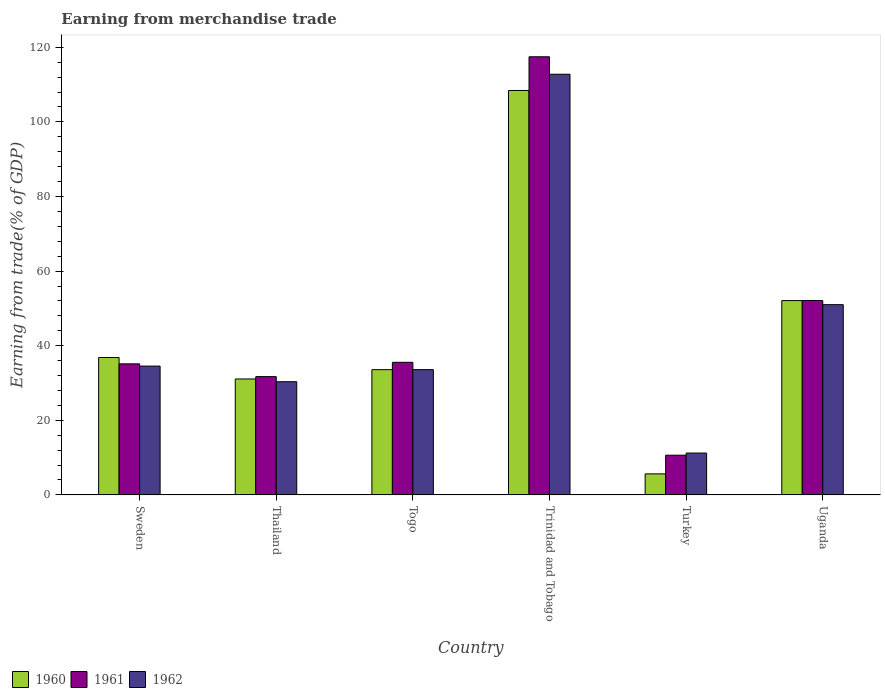How many groups of bars are there?
Your answer should be compact. 6. Are the number of bars per tick equal to the number of legend labels?
Your response must be concise. Yes. Are the number of bars on each tick of the X-axis equal?
Your answer should be compact. Yes. How many bars are there on the 2nd tick from the left?
Ensure brevity in your answer.  3. How many bars are there on the 5th tick from the right?
Provide a succinct answer. 3. What is the label of the 3rd group of bars from the left?
Make the answer very short. Togo. In how many cases, is the number of bars for a given country not equal to the number of legend labels?
Provide a succinct answer. 0. What is the earnings from trade in 1960 in Togo?
Give a very brief answer. 33.58. Across all countries, what is the maximum earnings from trade in 1961?
Ensure brevity in your answer.  117.45. Across all countries, what is the minimum earnings from trade in 1961?
Ensure brevity in your answer.  10.64. In which country was the earnings from trade in 1961 maximum?
Your response must be concise. Trinidad and Tobago. What is the total earnings from trade in 1962 in the graph?
Offer a terse response. 273.44. What is the difference between the earnings from trade in 1960 in Turkey and that in Uganda?
Provide a short and direct response. -46.45. What is the difference between the earnings from trade in 1962 in Uganda and the earnings from trade in 1961 in Sweden?
Make the answer very short. 15.86. What is the average earnings from trade in 1961 per country?
Your answer should be very brief. 47.1. What is the difference between the earnings from trade of/in 1961 and earnings from trade of/in 1962 in Sweden?
Keep it short and to the point. 0.6. In how many countries, is the earnings from trade in 1961 greater than 108 %?
Keep it short and to the point. 1. What is the ratio of the earnings from trade in 1962 in Togo to that in Trinidad and Tobago?
Ensure brevity in your answer.  0.3. Is the difference between the earnings from trade in 1961 in Sweden and Togo greater than the difference between the earnings from trade in 1962 in Sweden and Togo?
Ensure brevity in your answer.  No. What is the difference between the highest and the second highest earnings from trade in 1962?
Make the answer very short. 61.77. What is the difference between the highest and the lowest earnings from trade in 1960?
Provide a succinct answer. 102.78. In how many countries, is the earnings from trade in 1960 greater than the average earnings from trade in 1960 taken over all countries?
Your answer should be very brief. 2. What does the 2nd bar from the left in Thailand represents?
Your answer should be very brief. 1961. Are all the bars in the graph horizontal?
Provide a short and direct response. No. How many countries are there in the graph?
Provide a short and direct response. 6. What is the difference between two consecutive major ticks on the Y-axis?
Provide a short and direct response. 20. Are the values on the major ticks of Y-axis written in scientific E-notation?
Make the answer very short. No. How many legend labels are there?
Ensure brevity in your answer.  3. How are the legend labels stacked?
Your answer should be compact. Horizontal. What is the title of the graph?
Your answer should be very brief. Earning from merchandise trade. What is the label or title of the Y-axis?
Provide a succinct answer. Earning from trade(% of GDP). What is the Earning from trade(% of GDP) in 1960 in Sweden?
Your answer should be compact. 36.83. What is the Earning from trade(% of GDP) of 1961 in Sweden?
Give a very brief answer. 35.13. What is the Earning from trade(% of GDP) in 1962 in Sweden?
Your answer should be very brief. 34.53. What is the Earning from trade(% of GDP) of 1960 in Thailand?
Your response must be concise. 31.08. What is the Earning from trade(% of GDP) in 1961 in Thailand?
Your response must be concise. 31.71. What is the Earning from trade(% of GDP) in 1962 in Thailand?
Give a very brief answer. 30.34. What is the Earning from trade(% of GDP) in 1960 in Togo?
Your answer should be very brief. 33.58. What is the Earning from trade(% of GDP) of 1961 in Togo?
Offer a very short reply. 35.55. What is the Earning from trade(% of GDP) in 1962 in Togo?
Give a very brief answer. 33.58. What is the Earning from trade(% of GDP) in 1960 in Trinidad and Tobago?
Keep it short and to the point. 108.42. What is the Earning from trade(% of GDP) in 1961 in Trinidad and Tobago?
Provide a short and direct response. 117.45. What is the Earning from trade(% of GDP) of 1962 in Trinidad and Tobago?
Give a very brief answer. 112.77. What is the Earning from trade(% of GDP) in 1960 in Turkey?
Provide a short and direct response. 5.64. What is the Earning from trade(% of GDP) of 1961 in Turkey?
Provide a succinct answer. 10.64. What is the Earning from trade(% of GDP) in 1962 in Turkey?
Provide a short and direct response. 11.21. What is the Earning from trade(% of GDP) of 1960 in Uganda?
Your response must be concise. 52.09. What is the Earning from trade(% of GDP) of 1961 in Uganda?
Keep it short and to the point. 52.12. What is the Earning from trade(% of GDP) in 1962 in Uganda?
Make the answer very short. 51. Across all countries, what is the maximum Earning from trade(% of GDP) in 1960?
Your answer should be compact. 108.42. Across all countries, what is the maximum Earning from trade(% of GDP) in 1961?
Your answer should be very brief. 117.45. Across all countries, what is the maximum Earning from trade(% of GDP) of 1962?
Your answer should be compact. 112.77. Across all countries, what is the minimum Earning from trade(% of GDP) in 1960?
Your answer should be very brief. 5.64. Across all countries, what is the minimum Earning from trade(% of GDP) of 1961?
Keep it short and to the point. 10.64. Across all countries, what is the minimum Earning from trade(% of GDP) in 1962?
Keep it short and to the point. 11.21. What is the total Earning from trade(% of GDP) of 1960 in the graph?
Your answer should be very brief. 267.63. What is the total Earning from trade(% of GDP) in 1961 in the graph?
Ensure brevity in your answer.  282.6. What is the total Earning from trade(% of GDP) of 1962 in the graph?
Your answer should be very brief. 273.44. What is the difference between the Earning from trade(% of GDP) in 1960 in Sweden and that in Thailand?
Your response must be concise. 5.75. What is the difference between the Earning from trade(% of GDP) of 1961 in Sweden and that in Thailand?
Make the answer very short. 3.43. What is the difference between the Earning from trade(% of GDP) of 1962 in Sweden and that in Thailand?
Make the answer very short. 4.19. What is the difference between the Earning from trade(% of GDP) in 1960 in Sweden and that in Togo?
Ensure brevity in your answer.  3.25. What is the difference between the Earning from trade(% of GDP) of 1961 in Sweden and that in Togo?
Keep it short and to the point. -0.41. What is the difference between the Earning from trade(% of GDP) of 1962 in Sweden and that in Togo?
Ensure brevity in your answer.  0.95. What is the difference between the Earning from trade(% of GDP) of 1960 in Sweden and that in Trinidad and Tobago?
Make the answer very short. -71.59. What is the difference between the Earning from trade(% of GDP) of 1961 in Sweden and that in Trinidad and Tobago?
Your answer should be compact. -82.32. What is the difference between the Earning from trade(% of GDP) in 1962 in Sweden and that in Trinidad and Tobago?
Offer a terse response. -78.24. What is the difference between the Earning from trade(% of GDP) in 1960 in Sweden and that in Turkey?
Provide a succinct answer. 31.2. What is the difference between the Earning from trade(% of GDP) of 1961 in Sweden and that in Turkey?
Make the answer very short. 24.49. What is the difference between the Earning from trade(% of GDP) in 1962 in Sweden and that in Turkey?
Provide a short and direct response. 23.32. What is the difference between the Earning from trade(% of GDP) in 1960 in Sweden and that in Uganda?
Your answer should be very brief. -15.26. What is the difference between the Earning from trade(% of GDP) of 1961 in Sweden and that in Uganda?
Your response must be concise. -16.99. What is the difference between the Earning from trade(% of GDP) of 1962 in Sweden and that in Uganda?
Your answer should be compact. -16.46. What is the difference between the Earning from trade(% of GDP) of 1960 in Thailand and that in Togo?
Your answer should be compact. -2.5. What is the difference between the Earning from trade(% of GDP) of 1961 in Thailand and that in Togo?
Make the answer very short. -3.84. What is the difference between the Earning from trade(% of GDP) in 1962 in Thailand and that in Togo?
Give a very brief answer. -3.24. What is the difference between the Earning from trade(% of GDP) in 1960 in Thailand and that in Trinidad and Tobago?
Your response must be concise. -77.34. What is the difference between the Earning from trade(% of GDP) in 1961 in Thailand and that in Trinidad and Tobago?
Provide a short and direct response. -85.74. What is the difference between the Earning from trade(% of GDP) of 1962 in Thailand and that in Trinidad and Tobago?
Offer a terse response. -82.43. What is the difference between the Earning from trade(% of GDP) in 1960 in Thailand and that in Turkey?
Ensure brevity in your answer.  25.44. What is the difference between the Earning from trade(% of GDP) in 1961 in Thailand and that in Turkey?
Ensure brevity in your answer.  21.06. What is the difference between the Earning from trade(% of GDP) in 1962 in Thailand and that in Turkey?
Give a very brief answer. 19.13. What is the difference between the Earning from trade(% of GDP) of 1960 in Thailand and that in Uganda?
Provide a succinct answer. -21.01. What is the difference between the Earning from trade(% of GDP) in 1961 in Thailand and that in Uganda?
Give a very brief answer. -20.41. What is the difference between the Earning from trade(% of GDP) of 1962 in Thailand and that in Uganda?
Keep it short and to the point. -20.65. What is the difference between the Earning from trade(% of GDP) in 1960 in Togo and that in Trinidad and Tobago?
Your answer should be compact. -74.84. What is the difference between the Earning from trade(% of GDP) in 1961 in Togo and that in Trinidad and Tobago?
Ensure brevity in your answer.  -81.9. What is the difference between the Earning from trade(% of GDP) in 1962 in Togo and that in Trinidad and Tobago?
Your response must be concise. -79.19. What is the difference between the Earning from trade(% of GDP) in 1960 in Togo and that in Turkey?
Provide a short and direct response. 27.94. What is the difference between the Earning from trade(% of GDP) of 1961 in Togo and that in Turkey?
Provide a short and direct response. 24.9. What is the difference between the Earning from trade(% of GDP) of 1962 in Togo and that in Turkey?
Provide a short and direct response. 22.37. What is the difference between the Earning from trade(% of GDP) in 1960 in Togo and that in Uganda?
Provide a succinct answer. -18.51. What is the difference between the Earning from trade(% of GDP) in 1961 in Togo and that in Uganda?
Offer a terse response. -16.57. What is the difference between the Earning from trade(% of GDP) of 1962 in Togo and that in Uganda?
Ensure brevity in your answer.  -17.41. What is the difference between the Earning from trade(% of GDP) of 1960 in Trinidad and Tobago and that in Turkey?
Your response must be concise. 102.78. What is the difference between the Earning from trade(% of GDP) in 1961 in Trinidad and Tobago and that in Turkey?
Give a very brief answer. 106.81. What is the difference between the Earning from trade(% of GDP) in 1962 in Trinidad and Tobago and that in Turkey?
Provide a succinct answer. 101.56. What is the difference between the Earning from trade(% of GDP) of 1960 in Trinidad and Tobago and that in Uganda?
Your answer should be very brief. 56.33. What is the difference between the Earning from trade(% of GDP) of 1961 in Trinidad and Tobago and that in Uganda?
Make the answer very short. 65.33. What is the difference between the Earning from trade(% of GDP) of 1962 in Trinidad and Tobago and that in Uganda?
Your answer should be compact. 61.77. What is the difference between the Earning from trade(% of GDP) in 1960 in Turkey and that in Uganda?
Give a very brief answer. -46.45. What is the difference between the Earning from trade(% of GDP) of 1961 in Turkey and that in Uganda?
Your answer should be very brief. -41.48. What is the difference between the Earning from trade(% of GDP) of 1962 in Turkey and that in Uganda?
Your answer should be very brief. -39.78. What is the difference between the Earning from trade(% of GDP) of 1960 in Sweden and the Earning from trade(% of GDP) of 1961 in Thailand?
Provide a succinct answer. 5.13. What is the difference between the Earning from trade(% of GDP) in 1960 in Sweden and the Earning from trade(% of GDP) in 1962 in Thailand?
Your answer should be very brief. 6.49. What is the difference between the Earning from trade(% of GDP) in 1961 in Sweden and the Earning from trade(% of GDP) in 1962 in Thailand?
Ensure brevity in your answer.  4.79. What is the difference between the Earning from trade(% of GDP) in 1960 in Sweden and the Earning from trade(% of GDP) in 1961 in Togo?
Provide a succinct answer. 1.29. What is the difference between the Earning from trade(% of GDP) in 1960 in Sweden and the Earning from trade(% of GDP) in 1962 in Togo?
Your answer should be compact. 3.25. What is the difference between the Earning from trade(% of GDP) in 1961 in Sweden and the Earning from trade(% of GDP) in 1962 in Togo?
Ensure brevity in your answer.  1.55. What is the difference between the Earning from trade(% of GDP) in 1960 in Sweden and the Earning from trade(% of GDP) in 1961 in Trinidad and Tobago?
Your answer should be compact. -80.62. What is the difference between the Earning from trade(% of GDP) of 1960 in Sweden and the Earning from trade(% of GDP) of 1962 in Trinidad and Tobago?
Make the answer very short. -75.94. What is the difference between the Earning from trade(% of GDP) in 1961 in Sweden and the Earning from trade(% of GDP) in 1962 in Trinidad and Tobago?
Offer a terse response. -77.64. What is the difference between the Earning from trade(% of GDP) in 1960 in Sweden and the Earning from trade(% of GDP) in 1961 in Turkey?
Offer a terse response. 26.19. What is the difference between the Earning from trade(% of GDP) of 1960 in Sweden and the Earning from trade(% of GDP) of 1962 in Turkey?
Your response must be concise. 25.62. What is the difference between the Earning from trade(% of GDP) in 1961 in Sweden and the Earning from trade(% of GDP) in 1962 in Turkey?
Keep it short and to the point. 23.92. What is the difference between the Earning from trade(% of GDP) of 1960 in Sweden and the Earning from trade(% of GDP) of 1961 in Uganda?
Your answer should be compact. -15.29. What is the difference between the Earning from trade(% of GDP) in 1960 in Sweden and the Earning from trade(% of GDP) in 1962 in Uganda?
Give a very brief answer. -14.16. What is the difference between the Earning from trade(% of GDP) of 1961 in Sweden and the Earning from trade(% of GDP) of 1962 in Uganda?
Give a very brief answer. -15.86. What is the difference between the Earning from trade(% of GDP) in 1960 in Thailand and the Earning from trade(% of GDP) in 1961 in Togo?
Ensure brevity in your answer.  -4.47. What is the difference between the Earning from trade(% of GDP) in 1960 in Thailand and the Earning from trade(% of GDP) in 1962 in Togo?
Make the answer very short. -2.51. What is the difference between the Earning from trade(% of GDP) of 1961 in Thailand and the Earning from trade(% of GDP) of 1962 in Togo?
Offer a terse response. -1.88. What is the difference between the Earning from trade(% of GDP) in 1960 in Thailand and the Earning from trade(% of GDP) in 1961 in Trinidad and Tobago?
Offer a terse response. -86.37. What is the difference between the Earning from trade(% of GDP) in 1960 in Thailand and the Earning from trade(% of GDP) in 1962 in Trinidad and Tobago?
Offer a terse response. -81.69. What is the difference between the Earning from trade(% of GDP) in 1961 in Thailand and the Earning from trade(% of GDP) in 1962 in Trinidad and Tobago?
Provide a succinct answer. -81.07. What is the difference between the Earning from trade(% of GDP) in 1960 in Thailand and the Earning from trade(% of GDP) in 1961 in Turkey?
Make the answer very short. 20.43. What is the difference between the Earning from trade(% of GDP) in 1960 in Thailand and the Earning from trade(% of GDP) in 1962 in Turkey?
Your answer should be compact. 19.86. What is the difference between the Earning from trade(% of GDP) in 1961 in Thailand and the Earning from trade(% of GDP) in 1962 in Turkey?
Provide a short and direct response. 20.49. What is the difference between the Earning from trade(% of GDP) of 1960 in Thailand and the Earning from trade(% of GDP) of 1961 in Uganda?
Offer a very short reply. -21.04. What is the difference between the Earning from trade(% of GDP) of 1960 in Thailand and the Earning from trade(% of GDP) of 1962 in Uganda?
Your answer should be compact. -19.92. What is the difference between the Earning from trade(% of GDP) of 1961 in Thailand and the Earning from trade(% of GDP) of 1962 in Uganda?
Provide a succinct answer. -19.29. What is the difference between the Earning from trade(% of GDP) in 1960 in Togo and the Earning from trade(% of GDP) in 1961 in Trinidad and Tobago?
Make the answer very short. -83.87. What is the difference between the Earning from trade(% of GDP) of 1960 in Togo and the Earning from trade(% of GDP) of 1962 in Trinidad and Tobago?
Offer a very short reply. -79.19. What is the difference between the Earning from trade(% of GDP) in 1961 in Togo and the Earning from trade(% of GDP) in 1962 in Trinidad and Tobago?
Your answer should be very brief. -77.23. What is the difference between the Earning from trade(% of GDP) of 1960 in Togo and the Earning from trade(% of GDP) of 1961 in Turkey?
Make the answer very short. 22.93. What is the difference between the Earning from trade(% of GDP) in 1960 in Togo and the Earning from trade(% of GDP) in 1962 in Turkey?
Offer a terse response. 22.36. What is the difference between the Earning from trade(% of GDP) in 1961 in Togo and the Earning from trade(% of GDP) in 1962 in Turkey?
Make the answer very short. 24.33. What is the difference between the Earning from trade(% of GDP) of 1960 in Togo and the Earning from trade(% of GDP) of 1961 in Uganda?
Your answer should be very brief. -18.54. What is the difference between the Earning from trade(% of GDP) in 1960 in Togo and the Earning from trade(% of GDP) in 1962 in Uganda?
Make the answer very short. -17.42. What is the difference between the Earning from trade(% of GDP) of 1961 in Togo and the Earning from trade(% of GDP) of 1962 in Uganda?
Provide a succinct answer. -15.45. What is the difference between the Earning from trade(% of GDP) in 1960 in Trinidad and Tobago and the Earning from trade(% of GDP) in 1961 in Turkey?
Your response must be concise. 97.77. What is the difference between the Earning from trade(% of GDP) of 1960 in Trinidad and Tobago and the Earning from trade(% of GDP) of 1962 in Turkey?
Ensure brevity in your answer.  97.2. What is the difference between the Earning from trade(% of GDP) of 1961 in Trinidad and Tobago and the Earning from trade(% of GDP) of 1962 in Turkey?
Provide a succinct answer. 106.24. What is the difference between the Earning from trade(% of GDP) in 1960 in Trinidad and Tobago and the Earning from trade(% of GDP) in 1961 in Uganda?
Provide a succinct answer. 56.3. What is the difference between the Earning from trade(% of GDP) in 1960 in Trinidad and Tobago and the Earning from trade(% of GDP) in 1962 in Uganda?
Make the answer very short. 57.42. What is the difference between the Earning from trade(% of GDP) in 1961 in Trinidad and Tobago and the Earning from trade(% of GDP) in 1962 in Uganda?
Provide a short and direct response. 66.45. What is the difference between the Earning from trade(% of GDP) of 1960 in Turkey and the Earning from trade(% of GDP) of 1961 in Uganda?
Ensure brevity in your answer.  -46.48. What is the difference between the Earning from trade(% of GDP) of 1960 in Turkey and the Earning from trade(% of GDP) of 1962 in Uganda?
Make the answer very short. -45.36. What is the difference between the Earning from trade(% of GDP) in 1961 in Turkey and the Earning from trade(% of GDP) in 1962 in Uganda?
Offer a terse response. -40.35. What is the average Earning from trade(% of GDP) of 1960 per country?
Provide a short and direct response. 44.61. What is the average Earning from trade(% of GDP) in 1961 per country?
Your answer should be compact. 47.1. What is the average Earning from trade(% of GDP) in 1962 per country?
Ensure brevity in your answer.  45.57. What is the difference between the Earning from trade(% of GDP) of 1960 and Earning from trade(% of GDP) of 1961 in Sweden?
Offer a very short reply. 1.7. What is the difference between the Earning from trade(% of GDP) in 1960 and Earning from trade(% of GDP) in 1962 in Sweden?
Make the answer very short. 2.3. What is the difference between the Earning from trade(% of GDP) in 1961 and Earning from trade(% of GDP) in 1962 in Sweden?
Make the answer very short. 0.6. What is the difference between the Earning from trade(% of GDP) of 1960 and Earning from trade(% of GDP) of 1961 in Thailand?
Ensure brevity in your answer.  -0.63. What is the difference between the Earning from trade(% of GDP) in 1960 and Earning from trade(% of GDP) in 1962 in Thailand?
Your answer should be very brief. 0.74. What is the difference between the Earning from trade(% of GDP) in 1961 and Earning from trade(% of GDP) in 1962 in Thailand?
Offer a terse response. 1.36. What is the difference between the Earning from trade(% of GDP) of 1960 and Earning from trade(% of GDP) of 1961 in Togo?
Offer a very short reply. -1.97. What is the difference between the Earning from trade(% of GDP) in 1960 and Earning from trade(% of GDP) in 1962 in Togo?
Your response must be concise. -0.01. What is the difference between the Earning from trade(% of GDP) of 1961 and Earning from trade(% of GDP) of 1962 in Togo?
Ensure brevity in your answer.  1.96. What is the difference between the Earning from trade(% of GDP) of 1960 and Earning from trade(% of GDP) of 1961 in Trinidad and Tobago?
Provide a short and direct response. -9.03. What is the difference between the Earning from trade(% of GDP) in 1960 and Earning from trade(% of GDP) in 1962 in Trinidad and Tobago?
Provide a succinct answer. -4.35. What is the difference between the Earning from trade(% of GDP) of 1961 and Earning from trade(% of GDP) of 1962 in Trinidad and Tobago?
Keep it short and to the point. 4.68. What is the difference between the Earning from trade(% of GDP) in 1960 and Earning from trade(% of GDP) in 1961 in Turkey?
Make the answer very short. -5.01. What is the difference between the Earning from trade(% of GDP) in 1960 and Earning from trade(% of GDP) in 1962 in Turkey?
Ensure brevity in your answer.  -5.58. What is the difference between the Earning from trade(% of GDP) in 1961 and Earning from trade(% of GDP) in 1962 in Turkey?
Your response must be concise. -0.57. What is the difference between the Earning from trade(% of GDP) of 1960 and Earning from trade(% of GDP) of 1961 in Uganda?
Your response must be concise. -0.03. What is the difference between the Earning from trade(% of GDP) of 1960 and Earning from trade(% of GDP) of 1962 in Uganda?
Make the answer very short. 1.09. What is the difference between the Earning from trade(% of GDP) of 1961 and Earning from trade(% of GDP) of 1962 in Uganda?
Your response must be concise. 1.12. What is the ratio of the Earning from trade(% of GDP) of 1960 in Sweden to that in Thailand?
Your response must be concise. 1.19. What is the ratio of the Earning from trade(% of GDP) in 1961 in Sweden to that in Thailand?
Your answer should be very brief. 1.11. What is the ratio of the Earning from trade(% of GDP) of 1962 in Sweden to that in Thailand?
Your answer should be compact. 1.14. What is the ratio of the Earning from trade(% of GDP) of 1960 in Sweden to that in Togo?
Your answer should be compact. 1.1. What is the ratio of the Earning from trade(% of GDP) in 1961 in Sweden to that in Togo?
Offer a terse response. 0.99. What is the ratio of the Earning from trade(% of GDP) in 1962 in Sweden to that in Togo?
Make the answer very short. 1.03. What is the ratio of the Earning from trade(% of GDP) in 1960 in Sweden to that in Trinidad and Tobago?
Your answer should be very brief. 0.34. What is the ratio of the Earning from trade(% of GDP) of 1961 in Sweden to that in Trinidad and Tobago?
Your answer should be very brief. 0.3. What is the ratio of the Earning from trade(% of GDP) of 1962 in Sweden to that in Trinidad and Tobago?
Your answer should be compact. 0.31. What is the ratio of the Earning from trade(% of GDP) of 1960 in Sweden to that in Turkey?
Offer a very short reply. 6.53. What is the ratio of the Earning from trade(% of GDP) in 1961 in Sweden to that in Turkey?
Provide a short and direct response. 3.3. What is the ratio of the Earning from trade(% of GDP) in 1962 in Sweden to that in Turkey?
Your answer should be compact. 3.08. What is the ratio of the Earning from trade(% of GDP) in 1960 in Sweden to that in Uganda?
Provide a succinct answer. 0.71. What is the ratio of the Earning from trade(% of GDP) in 1961 in Sweden to that in Uganda?
Give a very brief answer. 0.67. What is the ratio of the Earning from trade(% of GDP) of 1962 in Sweden to that in Uganda?
Your answer should be very brief. 0.68. What is the ratio of the Earning from trade(% of GDP) of 1960 in Thailand to that in Togo?
Provide a succinct answer. 0.93. What is the ratio of the Earning from trade(% of GDP) of 1961 in Thailand to that in Togo?
Your answer should be very brief. 0.89. What is the ratio of the Earning from trade(% of GDP) in 1962 in Thailand to that in Togo?
Provide a succinct answer. 0.9. What is the ratio of the Earning from trade(% of GDP) in 1960 in Thailand to that in Trinidad and Tobago?
Your answer should be very brief. 0.29. What is the ratio of the Earning from trade(% of GDP) of 1961 in Thailand to that in Trinidad and Tobago?
Keep it short and to the point. 0.27. What is the ratio of the Earning from trade(% of GDP) in 1962 in Thailand to that in Trinidad and Tobago?
Ensure brevity in your answer.  0.27. What is the ratio of the Earning from trade(% of GDP) of 1960 in Thailand to that in Turkey?
Ensure brevity in your answer.  5.51. What is the ratio of the Earning from trade(% of GDP) of 1961 in Thailand to that in Turkey?
Give a very brief answer. 2.98. What is the ratio of the Earning from trade(% of GDP) in 1962 in Thailand to that in Turkey?
Give a very brief answer. 2.71. What is the ratio of the Earning from trade(% of GDP) in 1960 in Thailand to that in Uganda?
Make the answer very short. 0.6. What is the ratio of the Earning from trade(% of GDP) of 1961 in Thailand to that in Uganda?
Give a very brief answer. 0.61. What is the ratio of the Earning from trade(% of GDP) of 1962 in Thailand to that in Uganda?
Your answer should be very brief. 0.59. What is the ratio of the Earning from trade(% of GDP) of 1960 in Togo to that in Trinidad and Tobago?
Your response must be concise. 0.31. What is the ratio of the Earning from trade(% of GDP) of 1961 in Togo to that in Trinidad and Tobago?
Offer a very short reply. 0.3. What is the ratio of the Earning from trade(% of GDP) in 1962 in Togo to that in Trinidad and Tobago?
Keep it short and to the point. 0.3. What is the ratio of the Earning from trade(% of GDP) of 1960 in Togo to that in Turkey?
Provide a succinct answer. 5.96. What is the ratio of the Earning from trade(% of GDP) of 1961 in Togo to that in Turkey?
Give a very brief answer. 3.34. What is the ratio of the Earning from trade(% of GDP) of 1962 in Togo to that in Turkey?
Ensure brevity in your answer.  2.99. What is the ratio of the Earning from trade(% of GDP) in 1960 in Togo to that in Uganda?
Offer a terse response. 0.64. What is the ratio of the Earning from trade(% of GDP) of 1961 in Togo to that in Uganda?
Your answer should be very brief. 0.68. What is the ratio of the Earning from trade(% of GDP) of 1962 in Togo to that in Uganda?
Your answer should be compact. 0.66. What is the ratio of the Earning from trade(% of GDP) in 1960 in Trinidad and Tobago to that in Turkey?
Offer a very short reply. 19.23. What is the ratio of the Earning from trade(% of GDP) in 1961 in Trinidad and Tobago to that in Turkey?
Your answer should be compact. 11.03. What is the ratio of the Earning from trade(% of GDP) in 1962 in Trinidad and Tobago to that in Turkey?
Provide a short and direct response. 10.06. What is the ratio of the Earning from trade(% of GDP) of 1960 in Trinidad and Tobago to that in Uganda?
Keep it short and to the point. 2.08. What is the ratio of the Earning from trade(% of GDP) of 1961 in Trinidad and Tobago to that in Uganda?
Provide a short and direct response. 2.25. What is the ratio of the Earning from trade(% of GDP) of 1962 in Trinidad and Tobago to that in Uganda?
Your answer should be compact. 2.21. What is the ratio of the Earning from trade(% of GDP) in 1960 in Turkey to that in Uganda?
Provide a short and direct response. 0.11. What is the ratio of the Earning from trade(% of GDP) in 1961 in Turkey to that in Uganda?
Your answer should be compact. 0.2. What is the ratio of the Earning from trade(% of GDP) of 1962 in Turkey to that in Uganda?
Make the answer very short. 0.22. What is the difference between the highest and the second highest Earning from trade(% of GDP) in 1960?
Offer a terse response. 56.33. What is the difference between the highest and the second highest Earning from trade(% of GDP) of 1961?
Offer a very short reply. 65.33. What is the difference between the highest and the second highest Earning from trade(% of GDP) in 1962?
Your answer should be compact. 61.77. What is the difference between the highest and the lowest Earning from trade(% of GDP) in 1960?
Provide a succinct answer. 102.78. What is the difference between the highest and the lowest Earning from trade(% of GDP) of 1961?
Keep it short and to the point. 106.81. What is the difference between the highest and the lowest Earning from trade(% of GDP) in 1962?
Offer a very short reply. 101.56. 